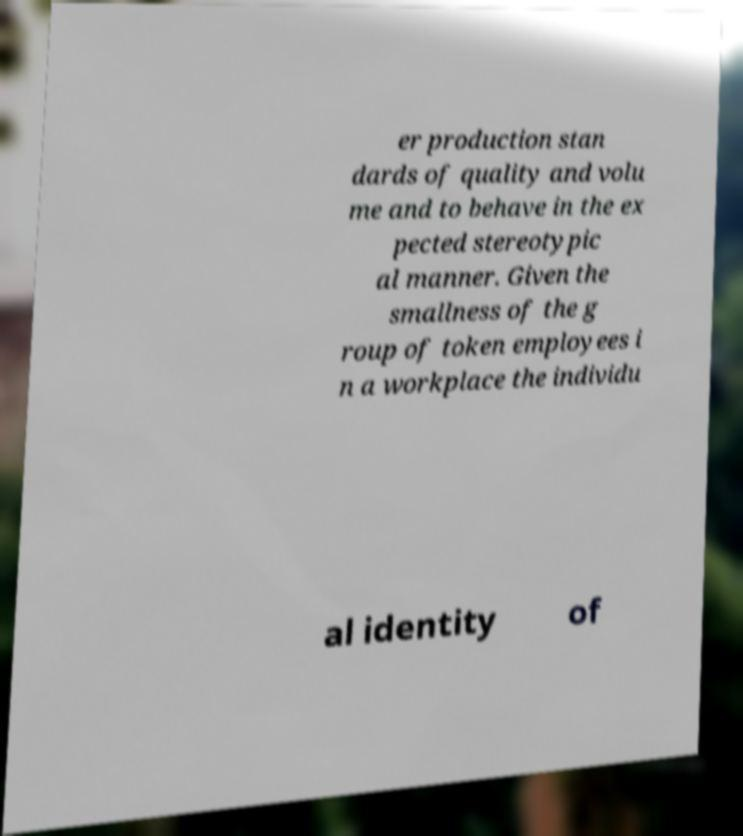Please identify and transcribe the text found in this image. er production stan dards of quality and volu me and to behave in the ex pected stereotypic al manner. Given the smallness of the g roup of token employees i n a workplace the individu al identity of 